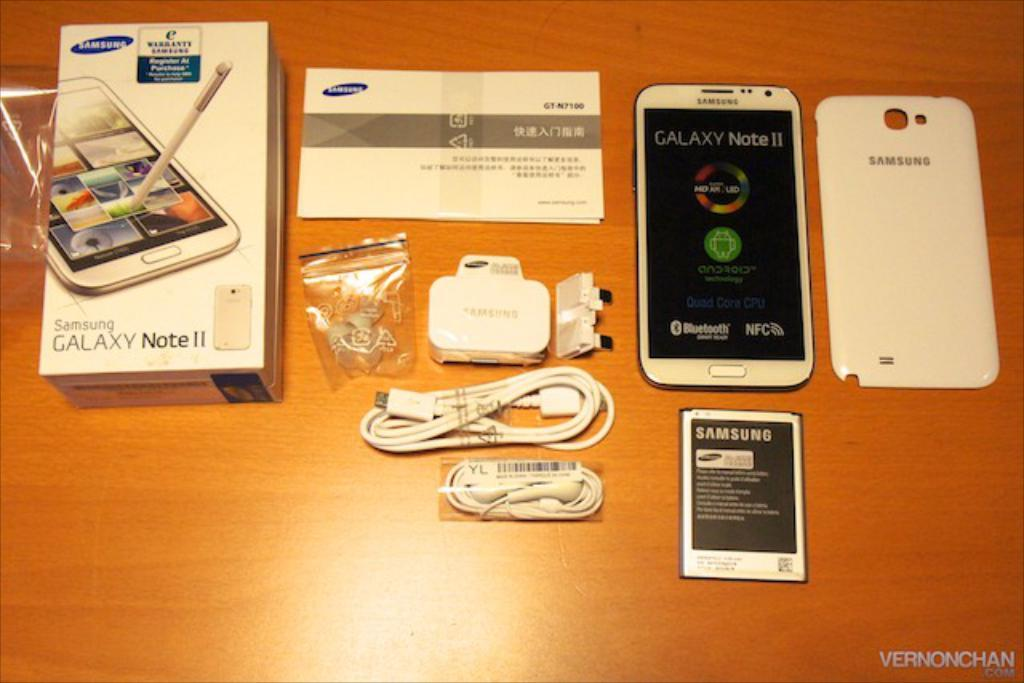<image>
Share a concise interpretation of the image provided. A Samsung Galaxy Note 2 with accessories on a table 